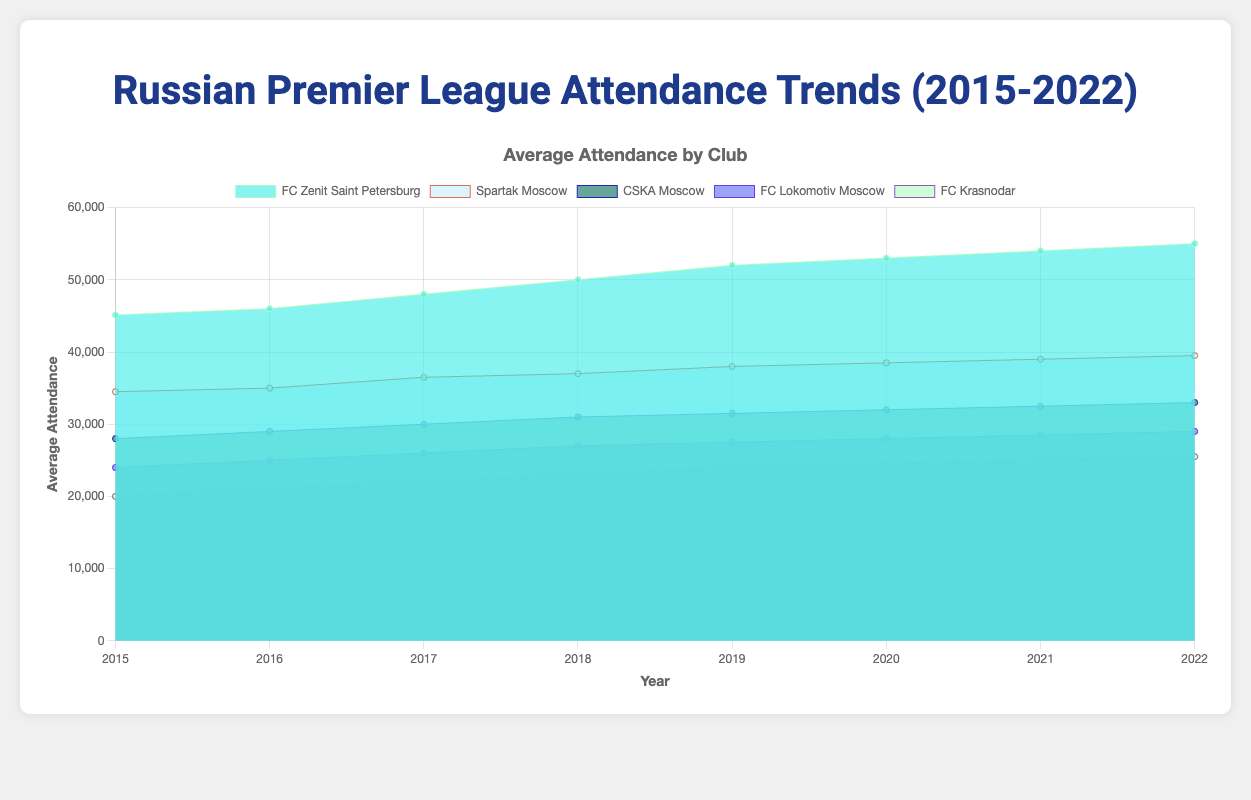What is the title of the figure? The title is often displayed at the top of the chart. In this case, it clearly states the central theme of the data.
Answer: Russian Premier League Attendance Trends (2015-2022) How many clubs are displayed in the chart? The legend at the top or side of the chart indicates different datasets. Here, each club's attendance is represented by a separate color.
Answer: Five Which club had the highest average attendance in 2022? Look for the highest data point on the y-axis for the year 2022 and match it with the corresponding club from the legend.
Answer: FC Zenit Saint Petersburg Did FC Zenit Saint Petersburg's attendance increase or decrease from 2015 to 2022? Compare FC Zenit Saint Petersburg’s data point for 2015 with that for 2022. An increasing trend line indicates growth.
Answer: Increase What was the average attendance for FC Krasnodar in 2018? Locate the 2018 data point for FC Krasnodar by matching the color for the club and reading the corresponding value on the y-axis.
Answer: 23,000 Which club had a greater increase in attendance between 2015 and 2022, Spartak Moscow or CSKA Moscow? Subtract the 2015 attendance from the 2022 attendance for both clubs and compare the differences.
Answer: Spartak Moscow (5,000 more compared to CSKA Moscow’s 5,000) What is the trend for FC Lokomotiv Moscow's attendance over the years? Analyze the data points of FC Lokomotiv Moscow from 2015 to 2022 and note the general direction of the line.
Answer: Increasing Among the five clubs, which had the lowest average attendance overall? Compare the y-axis values for all clubs across all years to determine the lowest overall attendance values.
Answer: FC Krasnodar How does Spartak Moscow's attendance in 2019 compare to FC Krasnodar in the same year? Match the 2019 data points for Spartak Moscow and FC Krasnodar, then compare the values to determine which is higher.
Answer: Spartak Moscow (38,000 compared to 24,000 for FC Krasnodar) Which club showed a steady increase in attendance every year from 2015 to 2022? Identify the trend lines for each club and check for a consistent upward slope throughout the given years.
Answer: FC Zenit Saint Petersburg 